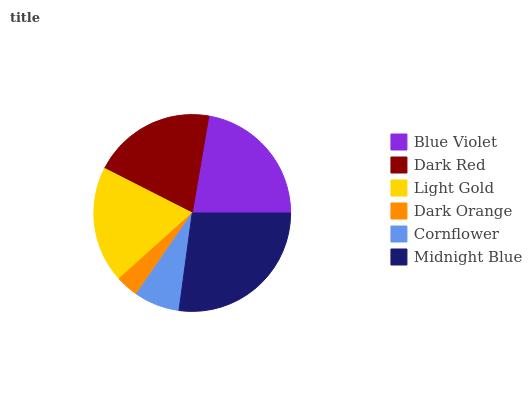Is Dark Orange the minimum?
Answer yes or no. Yes. Is Midnight Blue the maximum?
Answer yes or no. Yes. Is Dark Red the minimum?
Answer yes or no. No. Is Dark Red the maximum?
Answer yes or no. No. Is Blue Violet greater than Dark Red?
Answer yes or no. Yes. Is Dark Red less than Blue Violet?
Answer yes or no. Yes. Is Dark Red greater than Blue Violet?
Answer yes or no. No. Is Blue Violet less than Dark Red?
Answer yes or no. No. Is Dark Red the high median?
Answer yes or no. Yes. Is Light Gold the low median?
Answer yes or no. Yes. Is Blue Violet the high median?
Answer yes or no. No. Is Cornflower the low median?
Answer yes or no. No. 